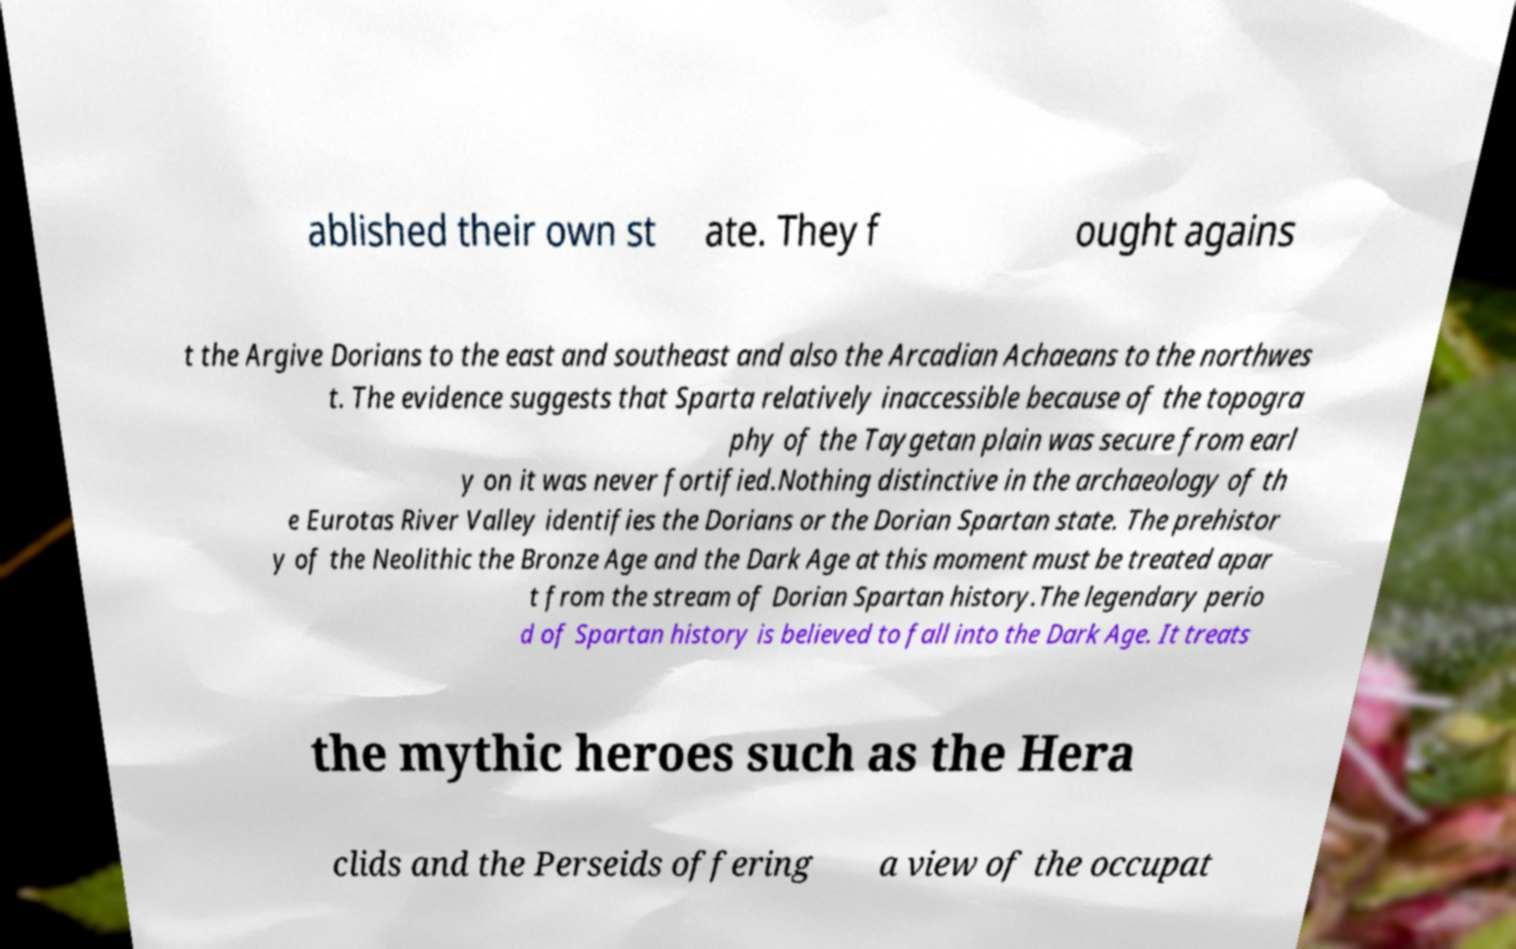There's text embedded in this image that I need extracted. Can you transcribe it verbatim? ablished their own st ate. They f ought agains t the Argive Dorians to the east and southeast and also the Arcadian Achaeans to the northwes t. The evidence suggests that Sparta relatively inaccessible because of the topogra phy of the Taygetan plain was secure from earl y on it was never fortified.Nothing distinctive in the archaeology of th e Eurotas River Valley identifies the Dorians or the Dorian Spartan state. The prehistor y of the Neolithic the Bronze Age and the Dark Age at this moment must be treated apar t from the stream of Dorian Spartan history.The legendary perio d of Spartan history is believed to fall into the Dark Age. It treats the mythic heroes such as the Hera clids and the Perseids offering a view of the occupat 